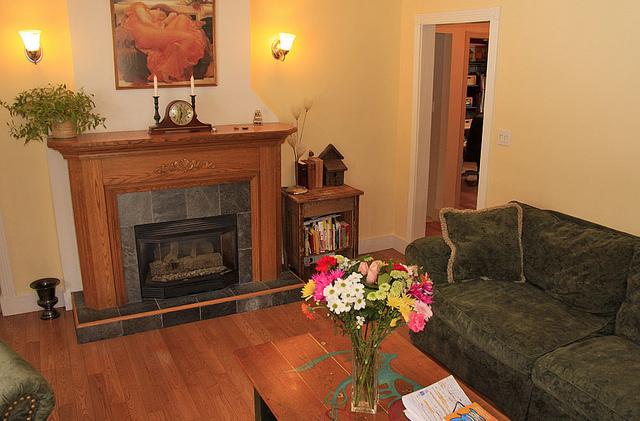What is the name of the orange flower?
Answer briefly. Daisy. Is there a couch in the room?
Quick response, please. Yes. Are there flowers in this picture?
Write a very short answer. Yes. Is there a clock on the mantle?
Answer briefly. Yes. 